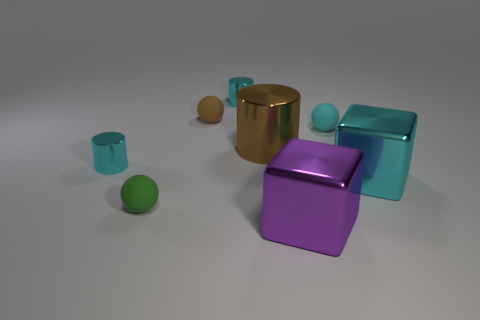Is the number of green balls on the left side of the purple shiny thing greater than the number of green cubes?
Ensure brevity in your answer.  Yes. What number of metal objects are either small cylinders or big purple blocks?
Keep it short and to the point. 3. How big is the cyan object that is in front of the small cyan matte sphere and on the right side of the purple cube?
Your response must be concise. Large. Is there a small green sphere to the right of the shiny cube that is to the left of the cyan shiny block?
Keep it short and to the point. No. There is a tiny green object; how many large purple things are left of it?
Your answer should be compact. 0. What is the color of the other big object that is the same shape as the large cyan thing?
Provide a succinct answer. Purple. Is the material of the purple cube right of the small brown ball the same as the sphere on the right side of the purple cube?
Provide a succinct answer. No. Is the color of the big metal cylinder the same as the small rubber ball behind the cyan sphere?
Make the answer very short. Yes. There is a tiny cyan object that is both to the right of the tiny brown sphere and in front of the tiny brown ball; what is its shape?
Provide a succinct answer. Sphere. What number of cyan metallic objects are there?
Keep it short and to the point. 3. 